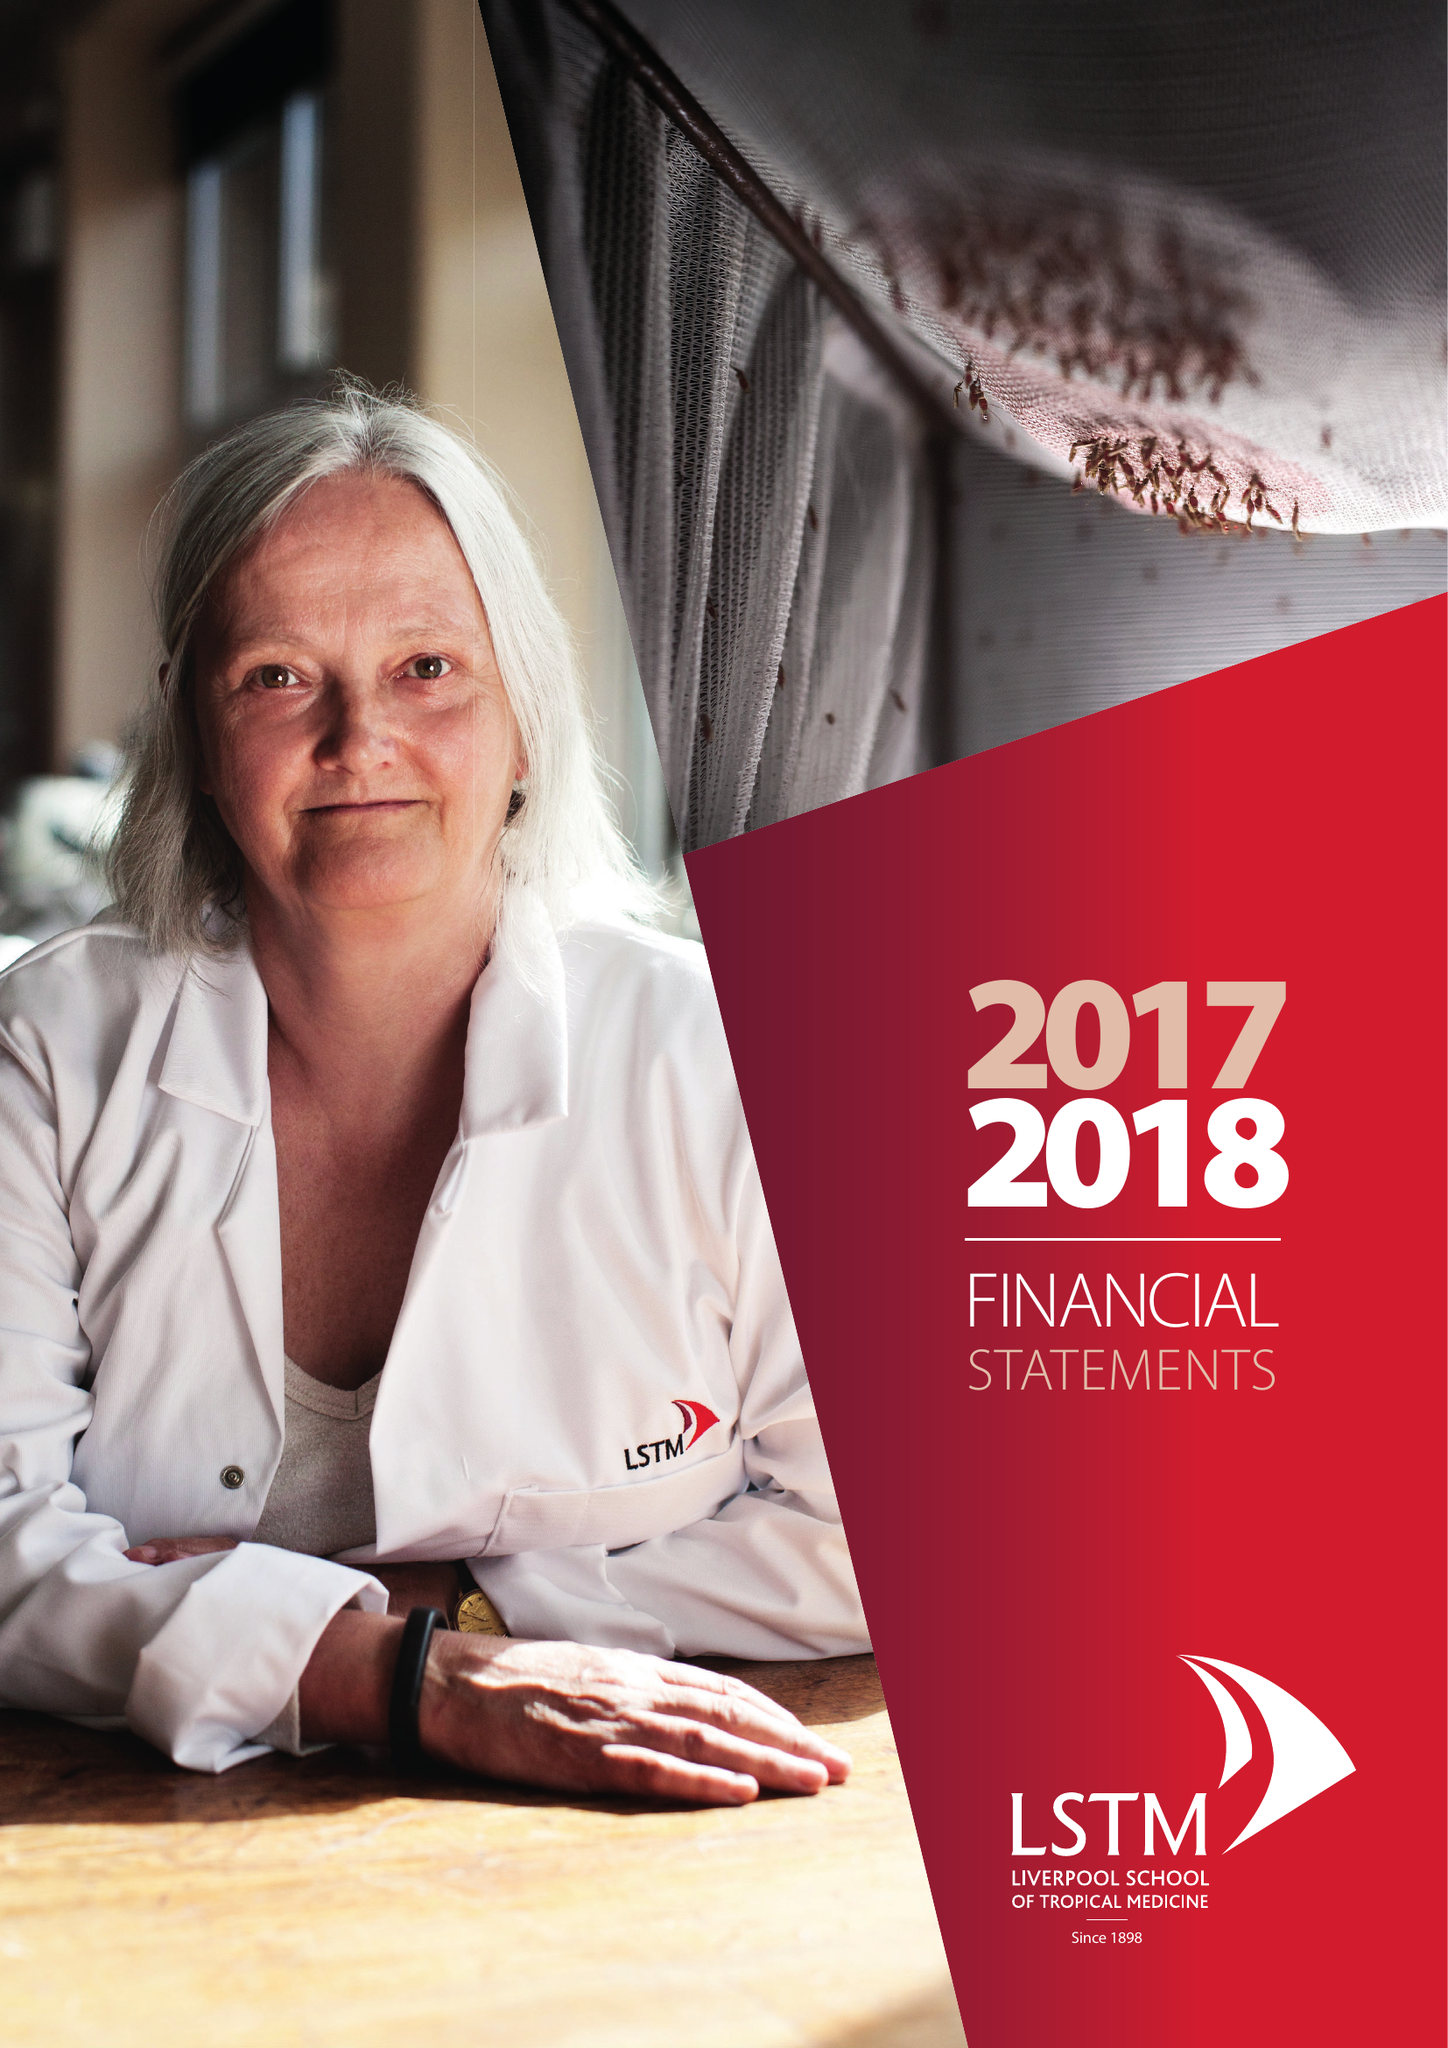What is the value for the charity_number?
Answer the question using a single word or phrase. 222655 